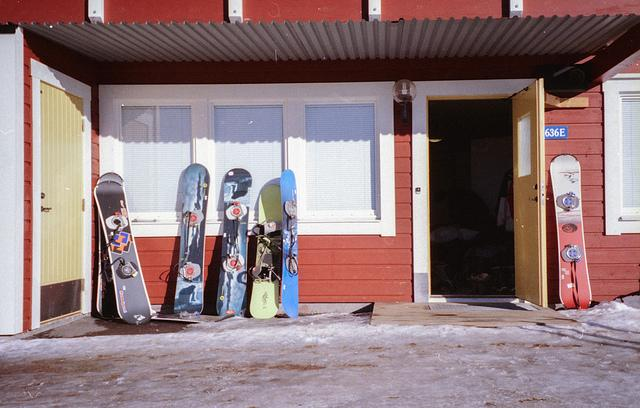What activity are the boards lined up against the building used for? Please explain your reasoning. snowboarding. This is similar to skiing but only one board is used 